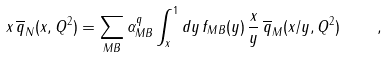<formula> <loc_0><loc_0><loc_500><loc_500>x \, \overline { q } _ { N } ( x , Q ^ { 2 } ) = \sum _ { M B } \alpha _ { M B } ^ { q } \int _ { x } ^ { 1 } d y \, f _ { M B } ( y ) \, \frac { x } { y } \, \overline { q } _ { M } ( x / y , Q ^ { 2 } ) \quad ,</formula> 